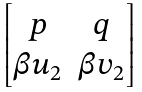<formula> <loc_0><loc_0><loc_500><loc_500>\begin{bmatrix} p & q \\ \beta u _ { 2 } & \beta v _ { 2 } \end{bmatrix}</formula> 